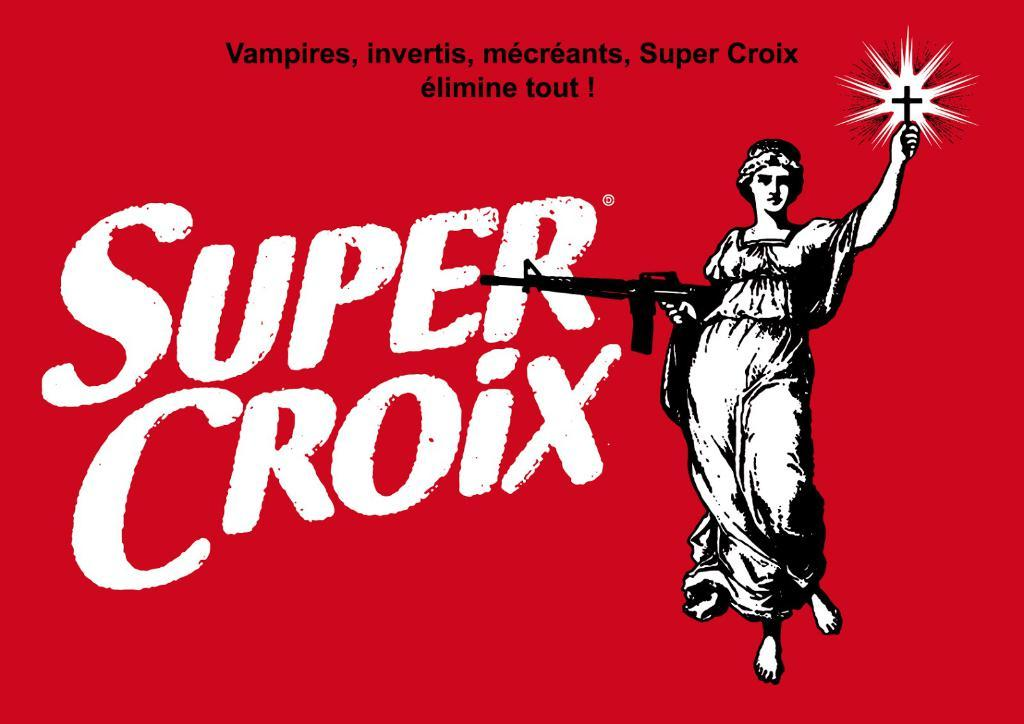<image>
Present a compact description of the photo's key features. A red sign has Super Croix next to a woman holding a gun. 